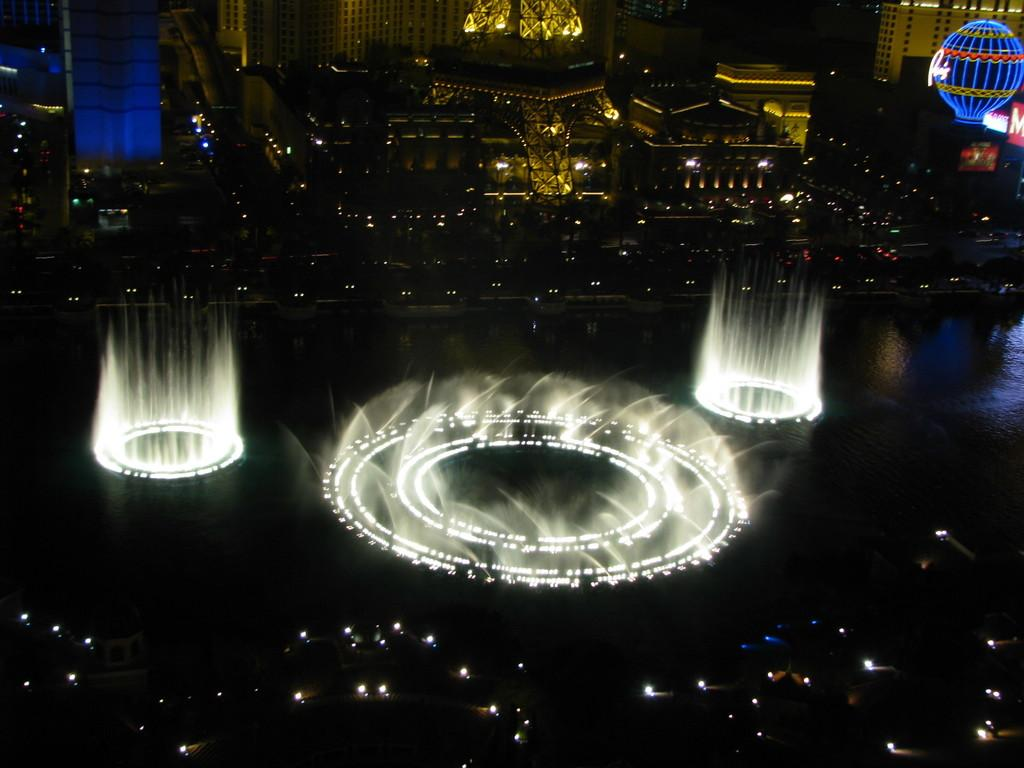What type of structures can be seen in the image? There are buildings in the image. What natural element is visible in the image? There is water visible in the image. What type of illumination is present in the image? There are lights in the image. What is the time of day or lighting condition when the image was taken? The image was taken in the dark. What type of frame is used to hold the discovery in the image? There is no discovery present in the image, and therefore no frame is needed to hold it. 